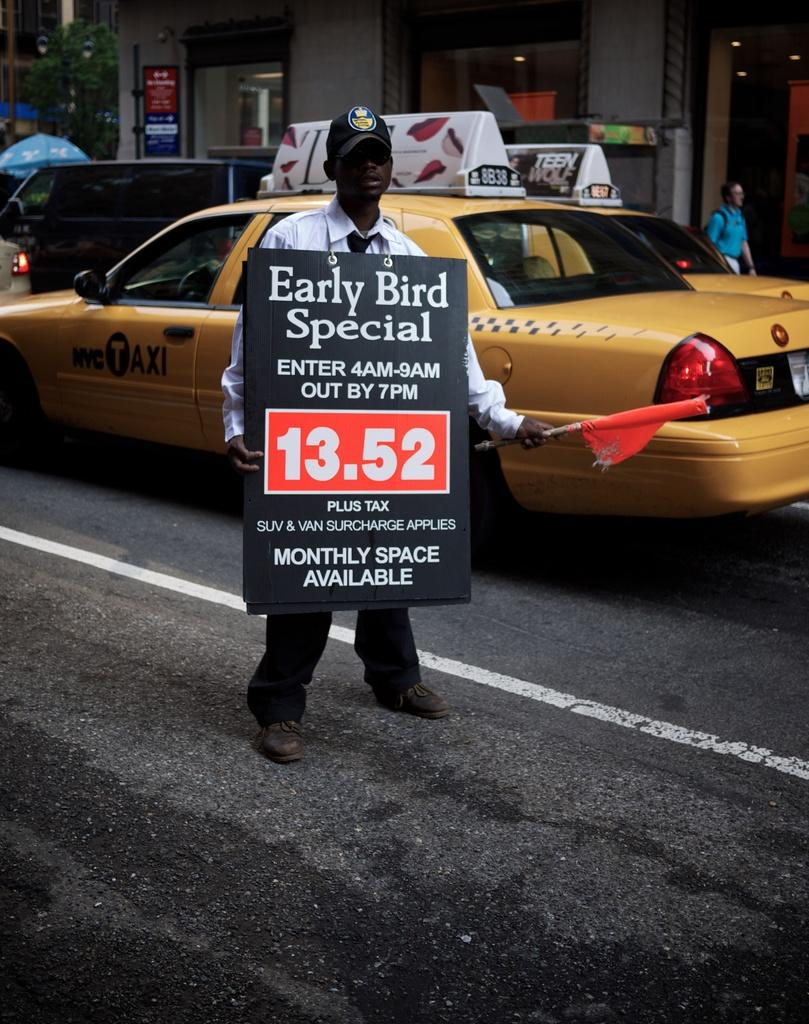<image>
Present a compact description of the photo's key features. The man is wearing a sign advertising an early bird special. 